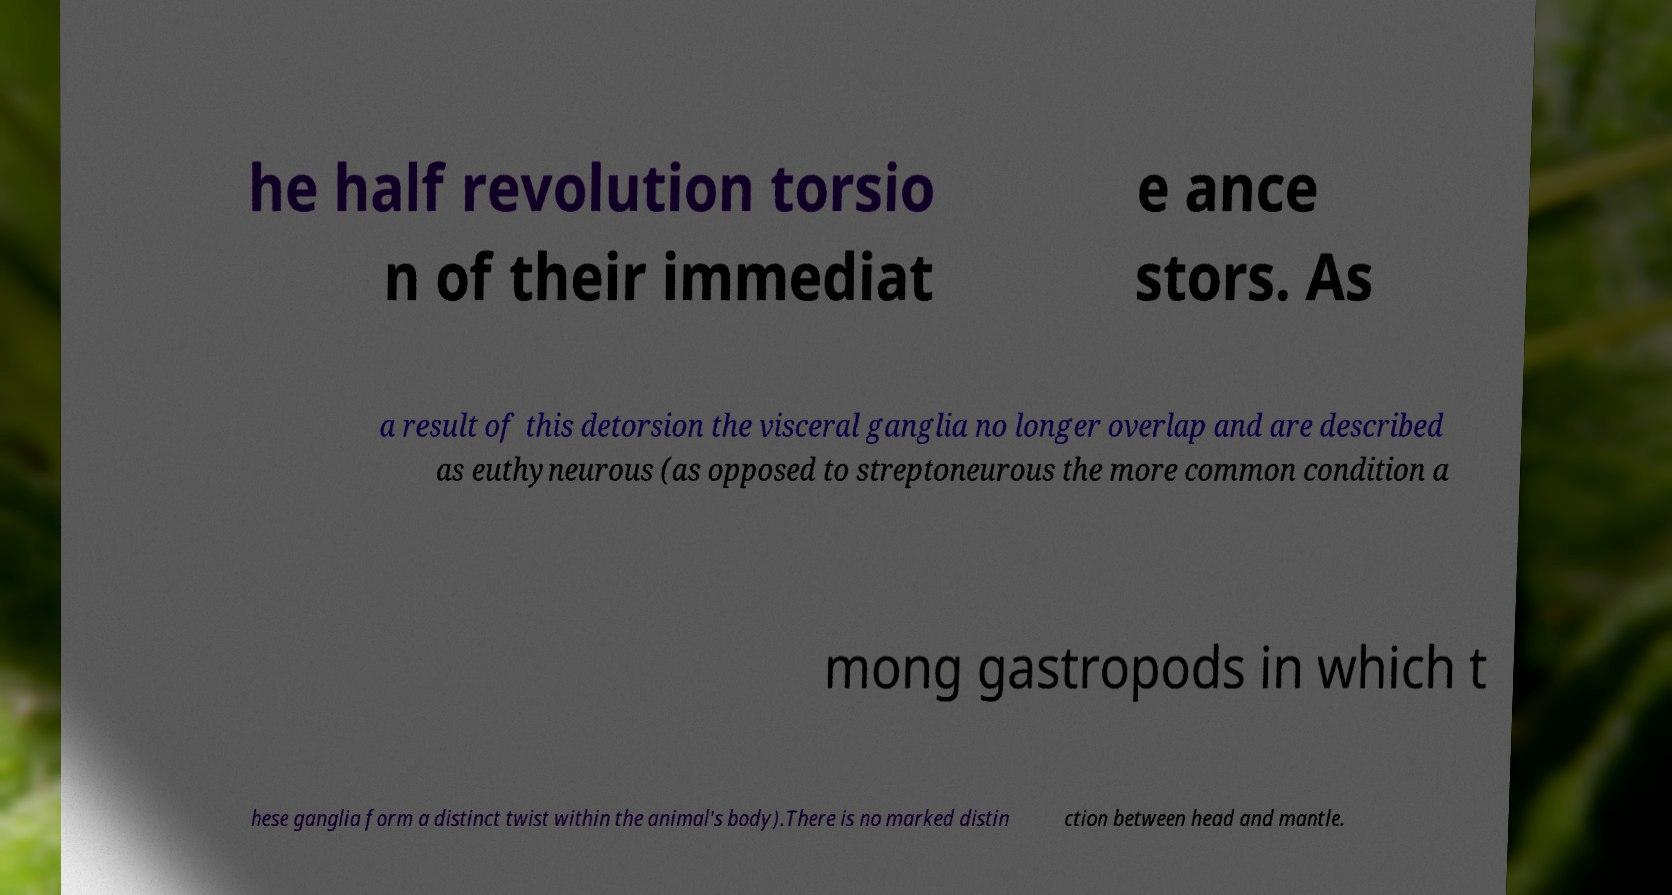Could you extract and type out the text from this image? he half revolution torsio n of their immediat e ance stors. As a result of this detorsion the visceral ganglia no longer overlap and are described as euthyneurous (as opposed to streptoneurous the more common condition a mong gastropods in which t hese ganglia form a distinct twist within the animal's body).There is no marked distin ction between head and mantle. 